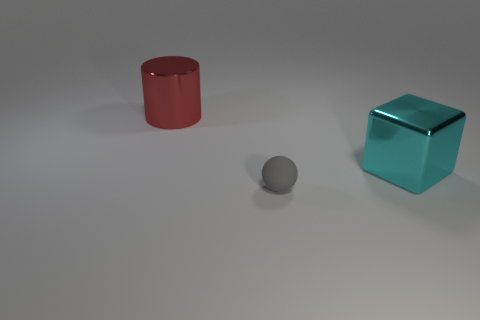How do the different surfaces of the objects reflect light? The red cylinder and the teal cube have shiny surfaces that reflect the lights, creating highlighted areas and reflections on the surfaces, while the gray sphere has a more matte finish, diffusing the light and resulting in a softer appearance. 